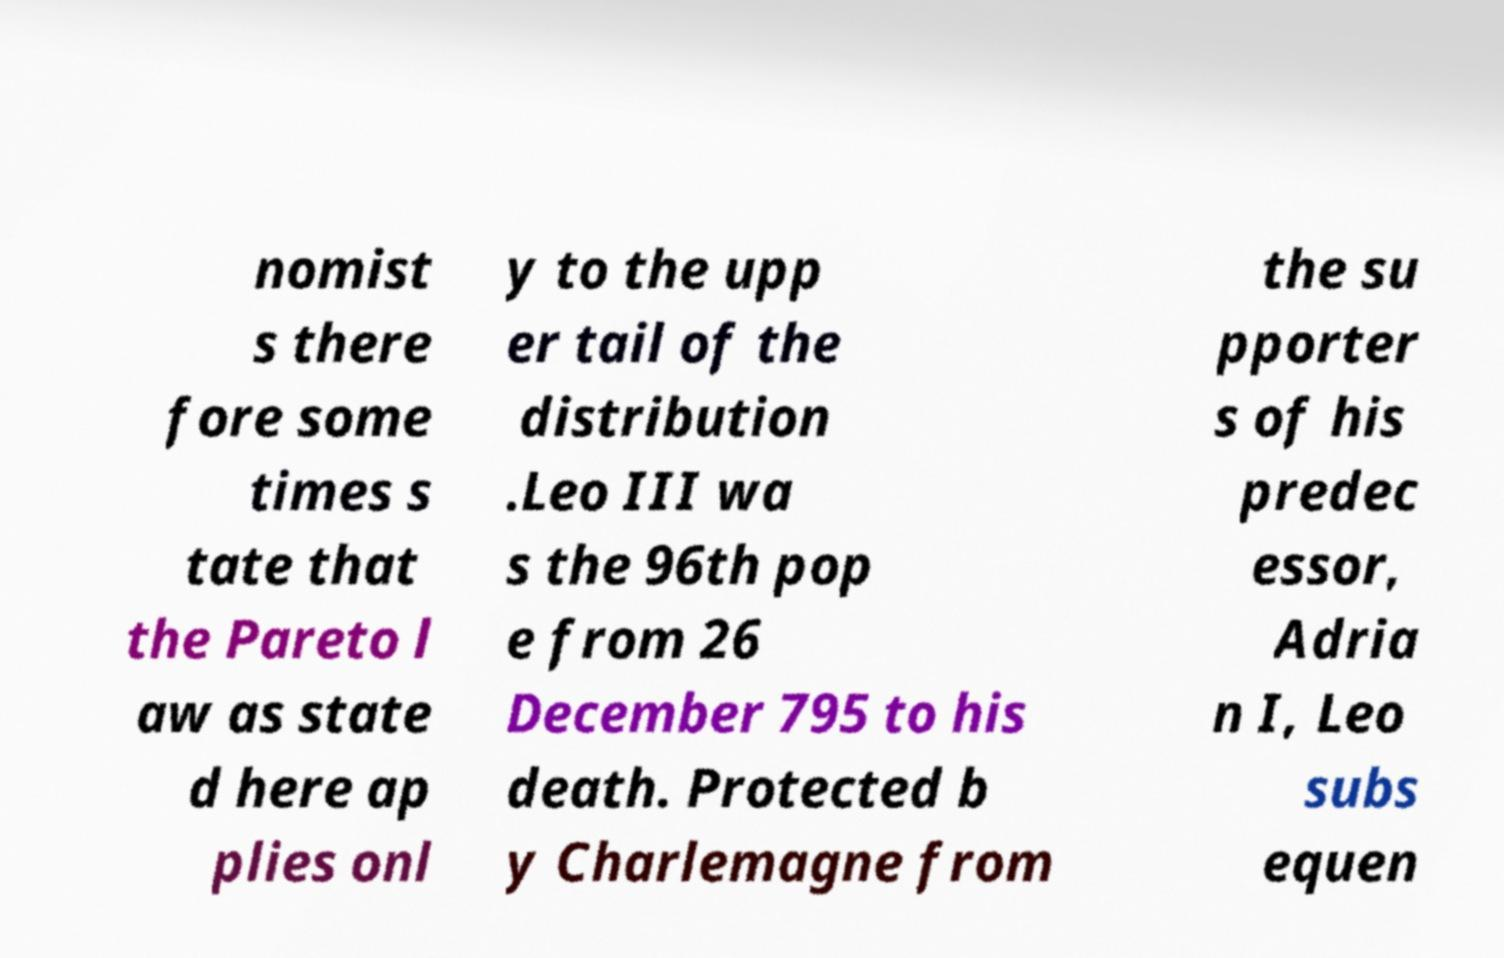For documentation purposes, I need the text within this image transcribed. Could you provide that? nomist s there fore some times s tate that the Pareto l aw as state d here ap plies onl y to the upp er tail of the distribution .Leo III wa s the 96th pop e from 26 December 795 to his death. Protected b y Charlemagne from the su pporter s of his predec essor, Adria n I, Leo subs equen 